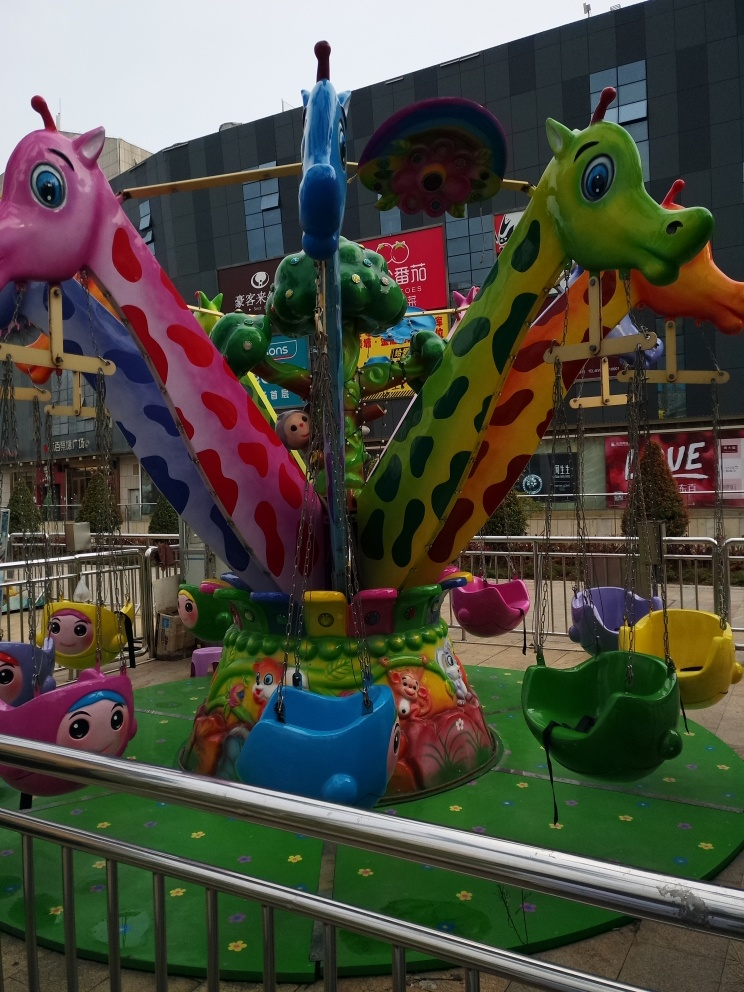What's happening in the image? This image features a vibrant children's carousel located outdoors, likely within an amusement area or park. The ride is adorned with whimsical animal figures, including creatures resembling a giraffe and a dragon, in a variety of bright colors and patterns, fun for kids to enjoy. 